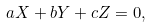Convert formula to latex. <formula><loc_0><loc_0><loc_500><loc_500>a X + b Y + c Z = 0 ,</formula> 